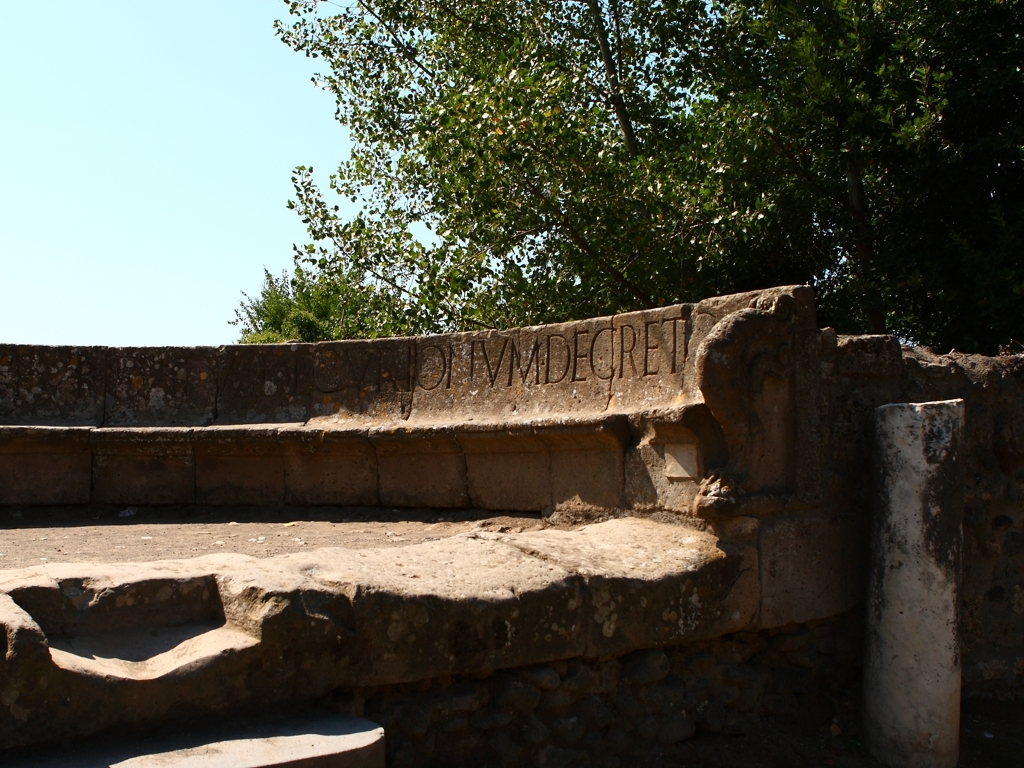Is the image free from motion blur? Upon careful examination, the image appears sharp without any signs of motion blur. The details of the ancient stone surfaces, including the inscriptions and weathered textures, are clearly visible and well-defined. Therefore, the correct answer is A. Yes, the image is free from motion blur, showcasing the historic structure’s features in a crisp manner. 